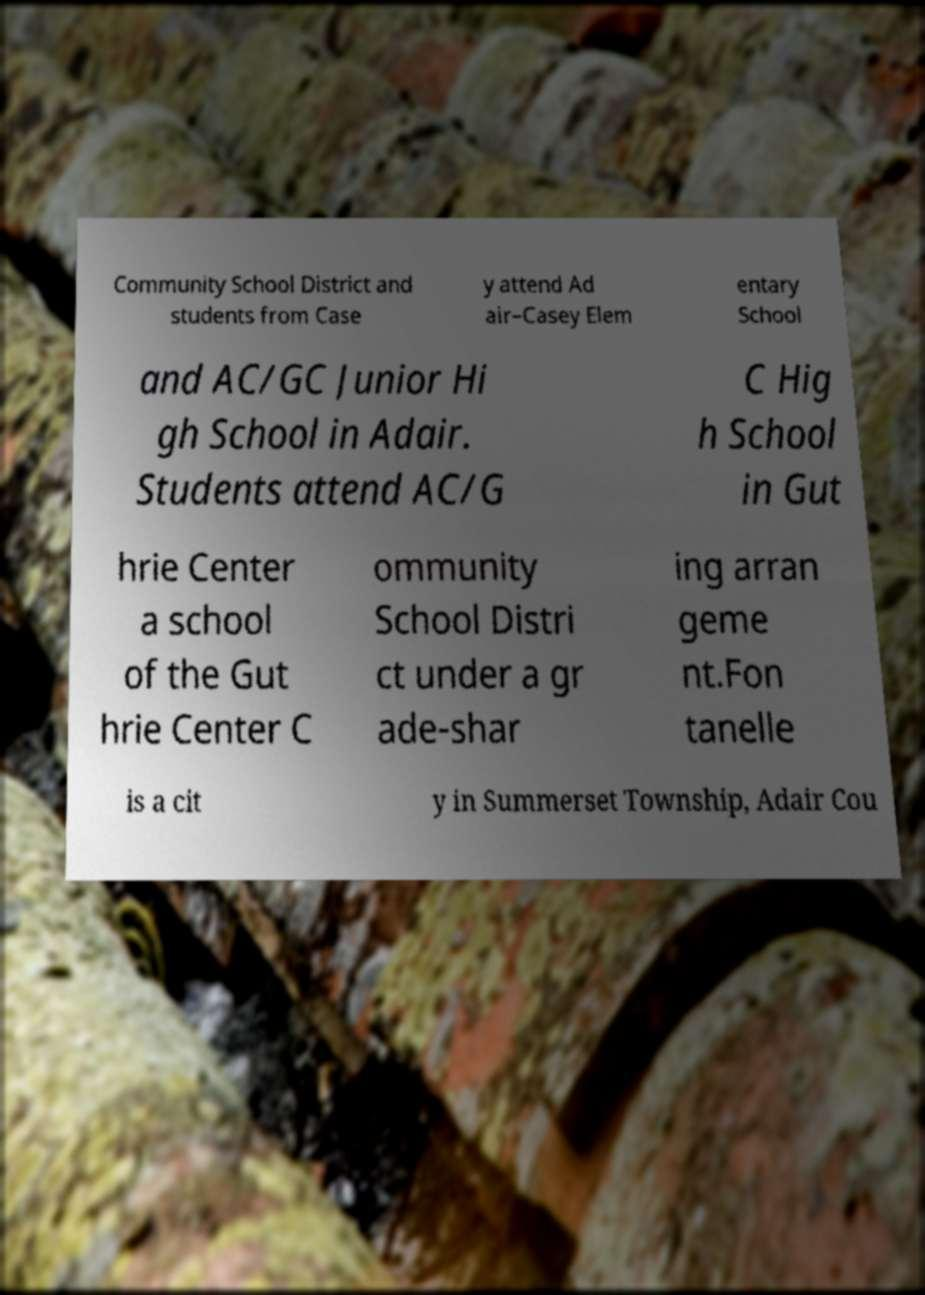Could you assist in decoding the text presented in this image and type it out clearly? Community School District and students from Case y attend Ad air–Casey Elem entary School and AC/GC Junior Hi gh School in Adair. Students attend AC/G C Hig h School in Gut hrie Center a school of the Gut hrie Center C ommunity School Distri ct under a gr ade-shar ing arran geme nt.Fon tanelle is a cit y in Summerset Township, Adair Cou 